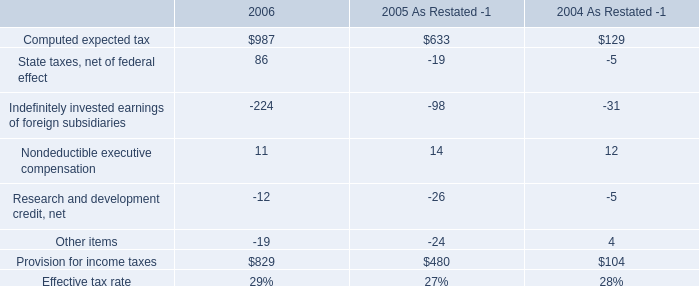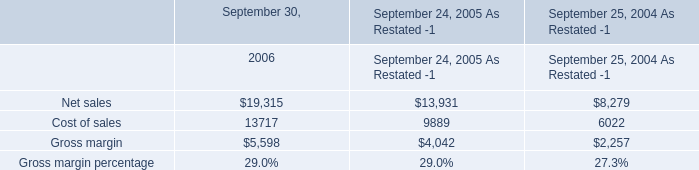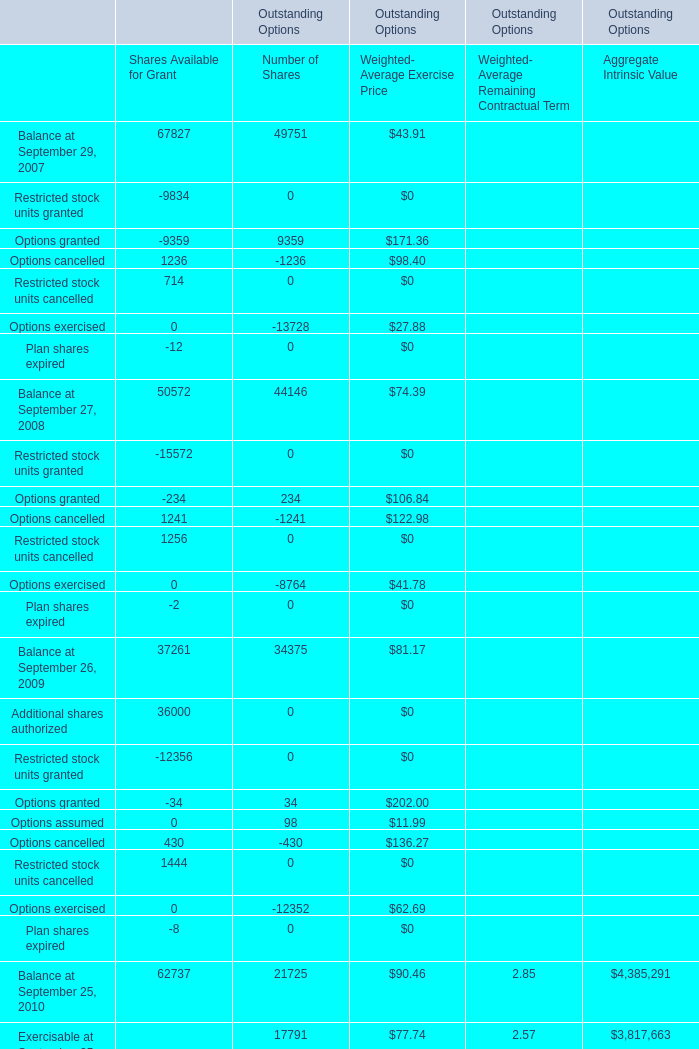What's the total amount of Shares Available for Grant excluding Balance at September 29, 2007 and Restricted stock units granted in 2007? 
Computations: (((-9359 + 1236) + 714) - 12)
Answer: -7421.0. 